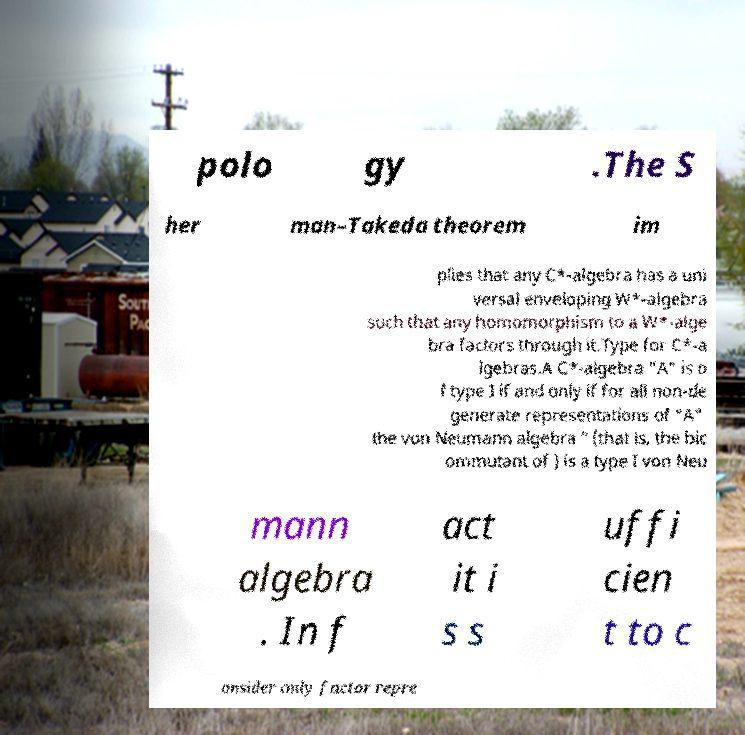Can you accurately transcribe the text from the provided image for me? polo gy .The S her man–Takeda theorem im plies that any C*-algebra has a uni versal enveloping W*-algebra such that any homomorphism to a W*-alge bra factors through it.Type for C*-a lgebras.A C*-algebra "A" is o f type I if and only if for all non-de generate representations of "A" the von Neumann algebra ′′ (that is, the bic ommutant of ) is a type I von Neu mann algebra . In f act it i s s uffi cien t to c onsider only factor repre 